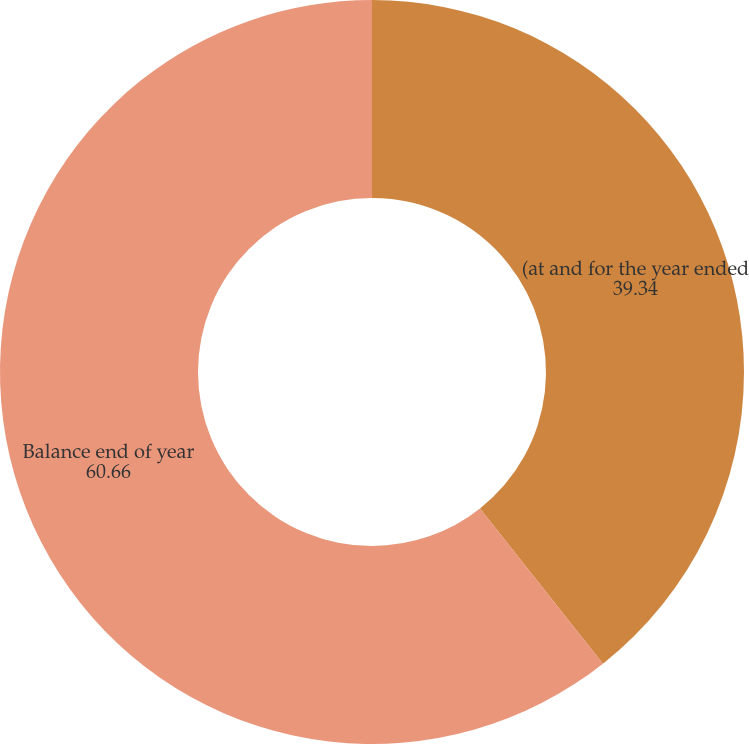Convert chart to OTSL. <chart><loc_0><loc_0><loc_500><loc_500><pie_chart><fcel>(at and for the year ended<fcel>Balance end of year<nl><fcel>39.34%<fcel>60.66%<nl></chart> 